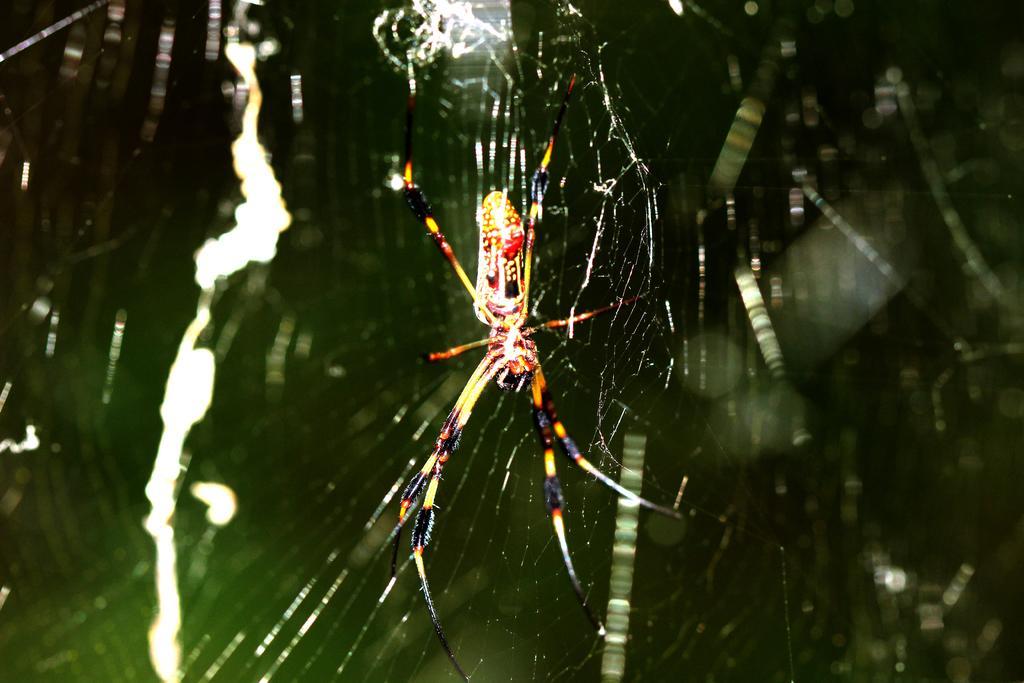In one or two sentences, can you explain what this image depicts? In this picture we can see a spider with web. In the background, the image is blurred. 